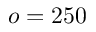<formula> <loc_0><loc_0><loc_500><loc_500>o = 2 5 0</formula> 